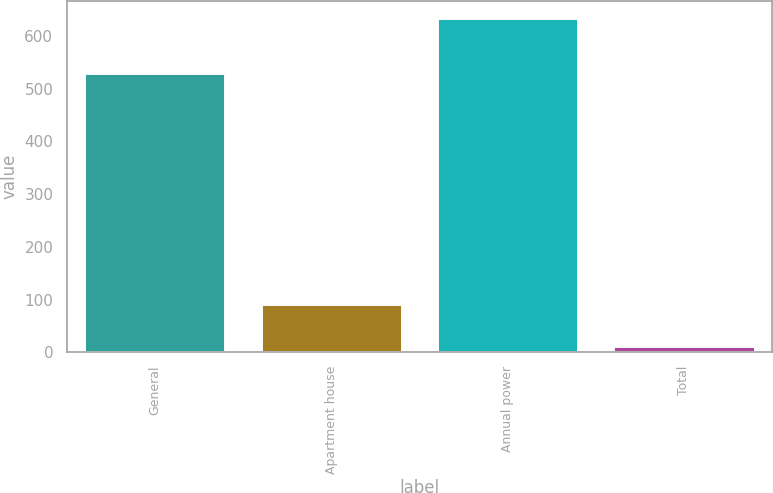<chart> <loc_0><loc_0><loc_500><loc_500><bar_chart><fcel>General<fcel>Apartment house<fcel>Annual power<fcel>Total<nl><fcel>529<fcel>92<fcel>634<fcel>13<nl></chart> 